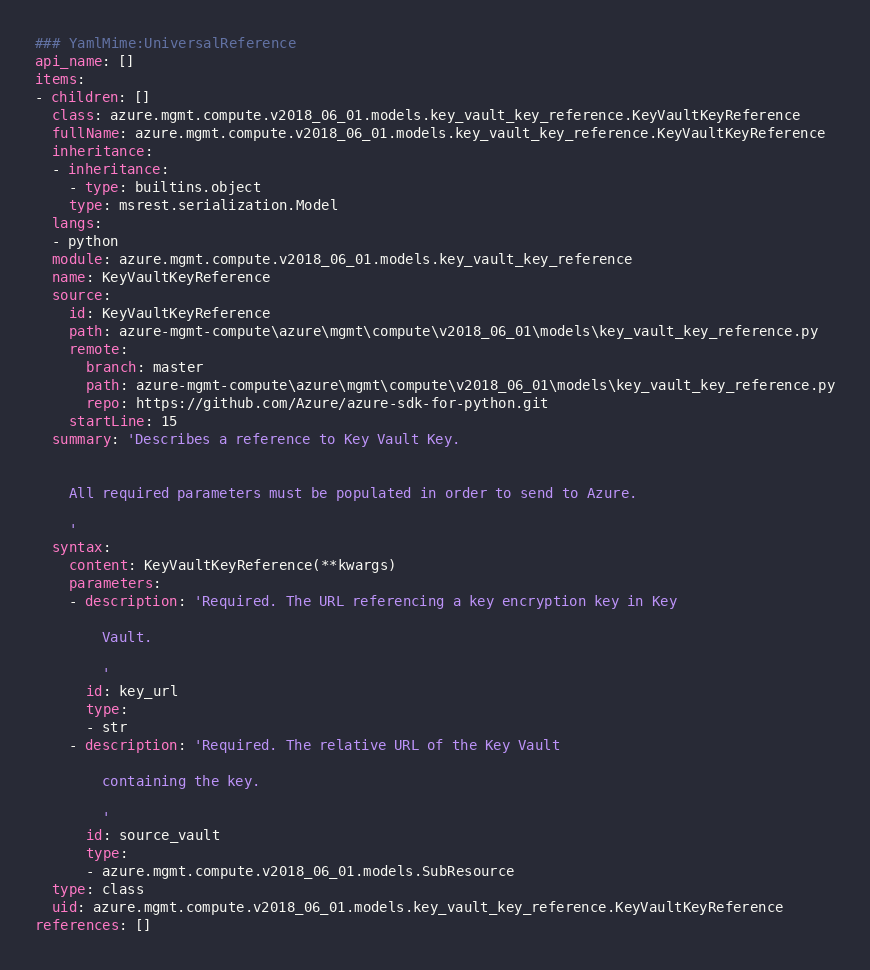Convert code to text. <code><loc_0><loc_0><loc_500><loc_500><_YAML_>### YamlMime:UniversalReference
api_name: []
items:
- children: []
  class: azure.mgmt.compute.v2018_06_01.models.key_vault_key_reference.KeyVaultKeyReference
  fullName: azure.mgmt.compute.v2018_06_01.models.key_vault_key_reference.KeyVaultKeyReference
  inheritance:
  - inheritance:
    - type: builtins.object
    type: msrest.serialization.Model
  langs:
  - python
  module: azure.mgmt.compute.v2018_06_01.models.key_vault_key_reference
  name: KeyVaultKeyReference
  source:
    id: KeyVaultKeyReference
    path: azure-mgmt-compute\azure\mgmt\compute\v2018_06_01\models\key_vault_key_reference.py
    remote:
      branch: master
      path: azure-mgmt-compute\azure\mgmt\compute\v2018_06_01\models\key_vault_key_reference.py
      repo: https://github.com/Azure/azure-sdk-for-python.git
    startLine: 15
  summary: 'Describes a reference to Key Vault Key.


    All required parameters must be populated in order to send to Azure.

    '
  syntax:
    content: KeyVaultKeyReference(**kwargs)
    parameters:
    - description: 'Required. The URL referencing a key encryption key in Key

        Vault.

        '
      id: key_url
      type:
      - str
    - description: 'Required. The relative URL of the Key Vault

        containing the key.

        '
      id: source_vault
      type:
      - azure.mgmt.compute.v2018_06_01.models.SubResource
  type: class
  uid: azure.mgmt.compute.v2018_06_01.models.key_vault_key_reference.KeyVaultKeyReference
references: []
</code> 